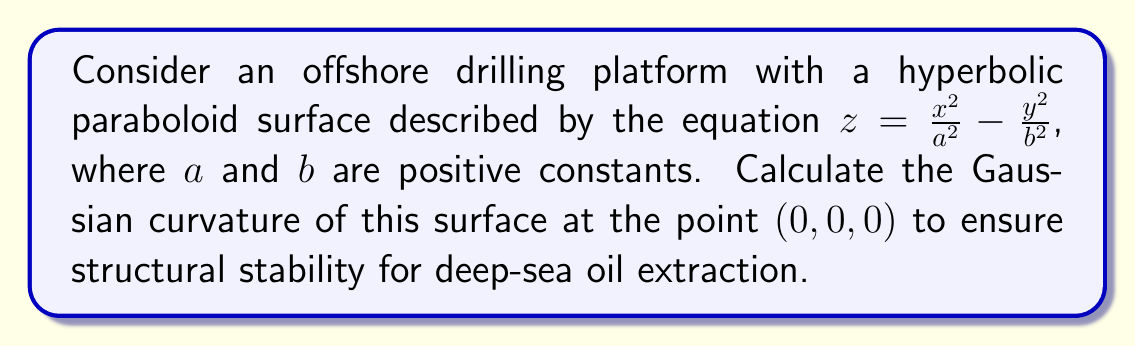Solve this math problem. To compute the Gaussian curvature of the hyperbolic paraboloid surface, we'll follow these steps:

1) The Gaussian curvature $K$ is given by $K = \frac{LN - M^2}{EG - F^2}$, where $E$, $F$, $G$ are the coefficients of the first fundamental form, and $L$, $M$, $N$ are the coefficients of the second fundamental form.

2) First, we need to calculate the partial derivatives:
   $z_x = \frac{2x}{a^2}$, $z_y = -\frac{2y}{b^2}$
   $z_{xx} = \frac{2}{a^2}$, $z_{xy} = 0$, $z_{yy} = -\frac{2}{b^2}$

3) At the point $(0,0,0)$:
   $z_x = 0$, $z_y = 0$
   $z_{xx} = \frac{2}{a^2}$, $z_{xy} = 0$, $z_{yy} = -\frac{2}{b^2}$

4) Calculate $E$, $F$, and $G$ at $(0,0,0)$:
   $E = 1 + z_x^2 = 1$
   $F = z_x z_y = 0$
   $G = 1 + z_y^2 = 1$

5) Calculate $L$, $M$, and $N$ at $(0,0,0)$:
   $L = \frac{z_{xx}}{\sqrt{1+z_x^2+z_y^2}} = \frac{2}{a^2}$
   $M = \frac{z_{xy}}{\sqrt{1+z_x^2+z_y^2}} = 0$
   $N = \frac{z_{yy}}{\sqrt{1+z_x^2+z_y^2}} = -\frac{2}{b^2}$

6) Now we can compute the Gaussian curvature:

   $$K = \frac{LN - M^2}{EG - F^2} = \frac{(\frac{2}{a^2})(-\frac{2}{b^2}) - 0^2}{(1)(1) - 0^2} = -\frac{4}{a^2b^2}$$

This negative value indicates that the surface is a saddle point at $(0,0,0)$, which is characteristic of a hyperbolic paraboloid.
Answer: $-\frac{4}{a^2b^2}$ 